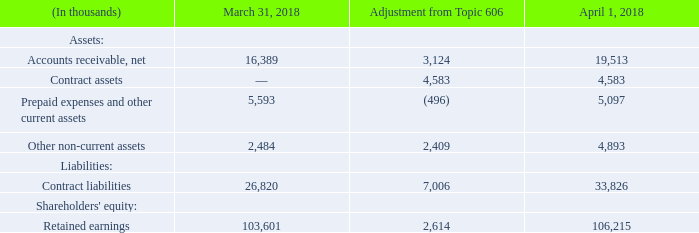Financial Statement Impact of Adoption on Previously Reported Results
We adopted Topic 606 using the modified retrospective method. The cumulative impact of applying the new guidance to all contracts with customers that were not completed as of April 1, 2018 was recorded as an adjustment to retained earnings as of the adoption date. As a result of applying the modified retrospective method to adopt the new standard, the following adjustments were made to noted accounts on the Consolidated Balance Sheet as of April 1, 2018:
The acceleration of revenue that was deferred under prior guidance as of the adoption date was primarily attributable to the requirement of Topic 606 to allocate the transaction price to the performance obligations in the contract on a relative basis using SSP rather than allocating under the residual method, which allocates the entire arrangement discount to the delivered performance obligations.
Due to the Company's full valuation allowance as of the adoption date, there is no tax impact associated with the adoption of Topic 606.
We made certain presentation changes to our Consolidated Balance Sheet on April 1, 2018 to comply with Topic 606. Prior to adoption of the new standard, we offset accounts receivable and contract liabilities (previously presented as deferred revenue on our Consolidated Balance Sheet) for unpaid deferred performance obligations included in contract liabilities.
Under the new standard, we record accounts receivable and related contract liabilities for non-cancelable contracts with customers when the right to consideration is unconditional. Upon adoption, the right to consideration in exchange for goods or services that have been transferred to a customer when that right is conditional on something other than the passage of time were reclassified from accounts receivable to contract assets.
What is the tax impact associated with the adoption of Topic 606? Due to the company's full valuation allowance as of the adoption date, there is no tax impact associated with the adoption of topic 606. What was the adjustment amount to accounts receivable, net?
Answer scale should be: thousand. 3,124. What was the adjustment amount to contract assets?
Answer scale should be: thousand. 4,583. What was the percentage change in  Accounts receivable, net after  Adjustment from Topic 606?
Answer scale should be: percent. 3,124/16,389 
Answer: 19.06. What was the percentage change in  Contract liabilities after  Adjustment from Topic 606?
Answer scale should be: percent. 7,006/26,820
Answer: 26.12. What was the percentage change in  Retained earnings after  Adjustment from Topic 606?
Answer scale should be: percent. 2,614/103,601 
Answer: 2.52. 